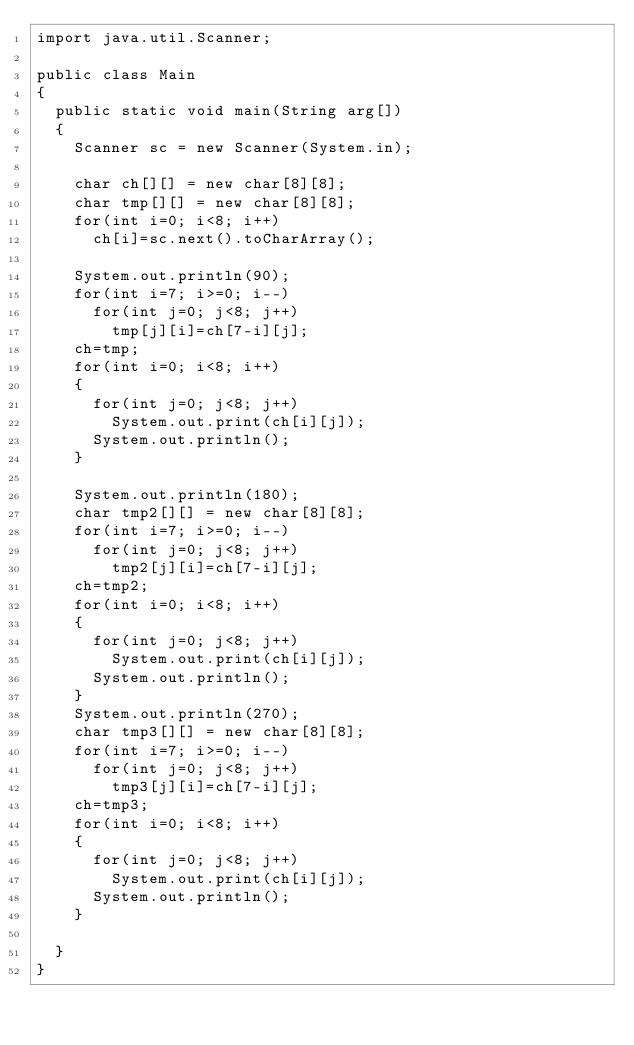Convert code to text. <code><loc_0><loc_0><loc_500><loc_500><_Java_>import java.util.Scanner;

public class Main
{
	public static void main(String arg[])
	{
		Scanner sc = new Scanner(System.in);

		char ch[][] = new char[8][8];
		char tmp[][] = new char[8][8];
		for(int i=0; i<8; i++)
			ch[i]=sc.next().toCharArray();

		System.out.println(90);
		for(int i=7; i>=0; i--)
			for(int j=0; j<8; j++)
				tmp[j][i]=ch[7-i][j];
		ch=tmp;
		for(int i=0; i<8; i++)
		{
			for(int j=0; j<8; j++)
				System.out.print(ch[i][j]);
			System.out.println();
		}
		
		System.out.println(180);
		char tmp2[][] = new char[8][8];
		for(int i=7; i>=0; i--)
			for(int j=0; j<8; j++)
				tmp2[j][i]=ch[7-i][j];
		ch=tmp2;
		for(int i=0; i<8; i++)
		{
			for(int j=0; j<8; j++)
				System.out.print(ch[i][j]);
			System.out.println();
		}
		System.out.println(270);
		char tmp3[][] = new char[8][8];
		for(int i=7; i>=0; i--)
			for(int j=0; j<8; j++)
				tmp3[j][i]=ch[7-i][j];
		ch=tmp3;
		for(int i=0; i<8; i++)
		{
			for(int j=0; j<8; j++)
				System.out.print(ch[i][j]);
			System.out.println();
		}
		
	}
}</code> 